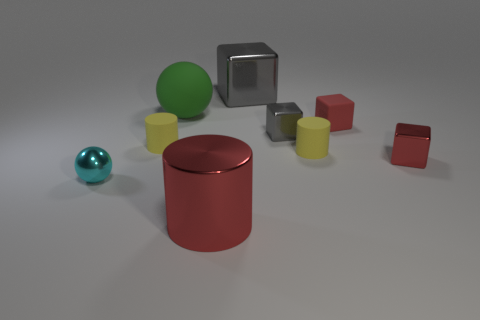What number of objects are left of the small gray shiny object and in front of the tiny gray metal cube?
Your answer should be compact. 3. What shape is the shiny thing that is the same color as the large cube?
Offer a very short reply. Cube. Is there any other thing that has the same material as the red cylinder?
Ensure brevity in your answer.  Yes. Do the tiny gray cube and the big green thing have the same material?
Provide a succinct answer. No. The tiny metal object that is left of the large metallic object that is in front of the ball that is on the left side of the large green sphere is what shape?
Provide a succinct answer. Sphere. Are there fewer large green rubber spheres right of the big green matte object than small gray metallic objects that are behind the big gray metal block?
Provide a succinct answer. No. The large matte object to the left of the tiny shiny object behind the small red metallic thing is what shape?
Ensure brevity in your answer.  Sphere. Is there any other thing of the same color as the matte sphere?
Provide a short and direct response. No. Is the color of the metallic cylinder the same as the small matte cube?
Your answer should be compact. Yes. How many cyan things are either tiny rubber cylinders or blocks?
Provide a short and direct response. 0. 